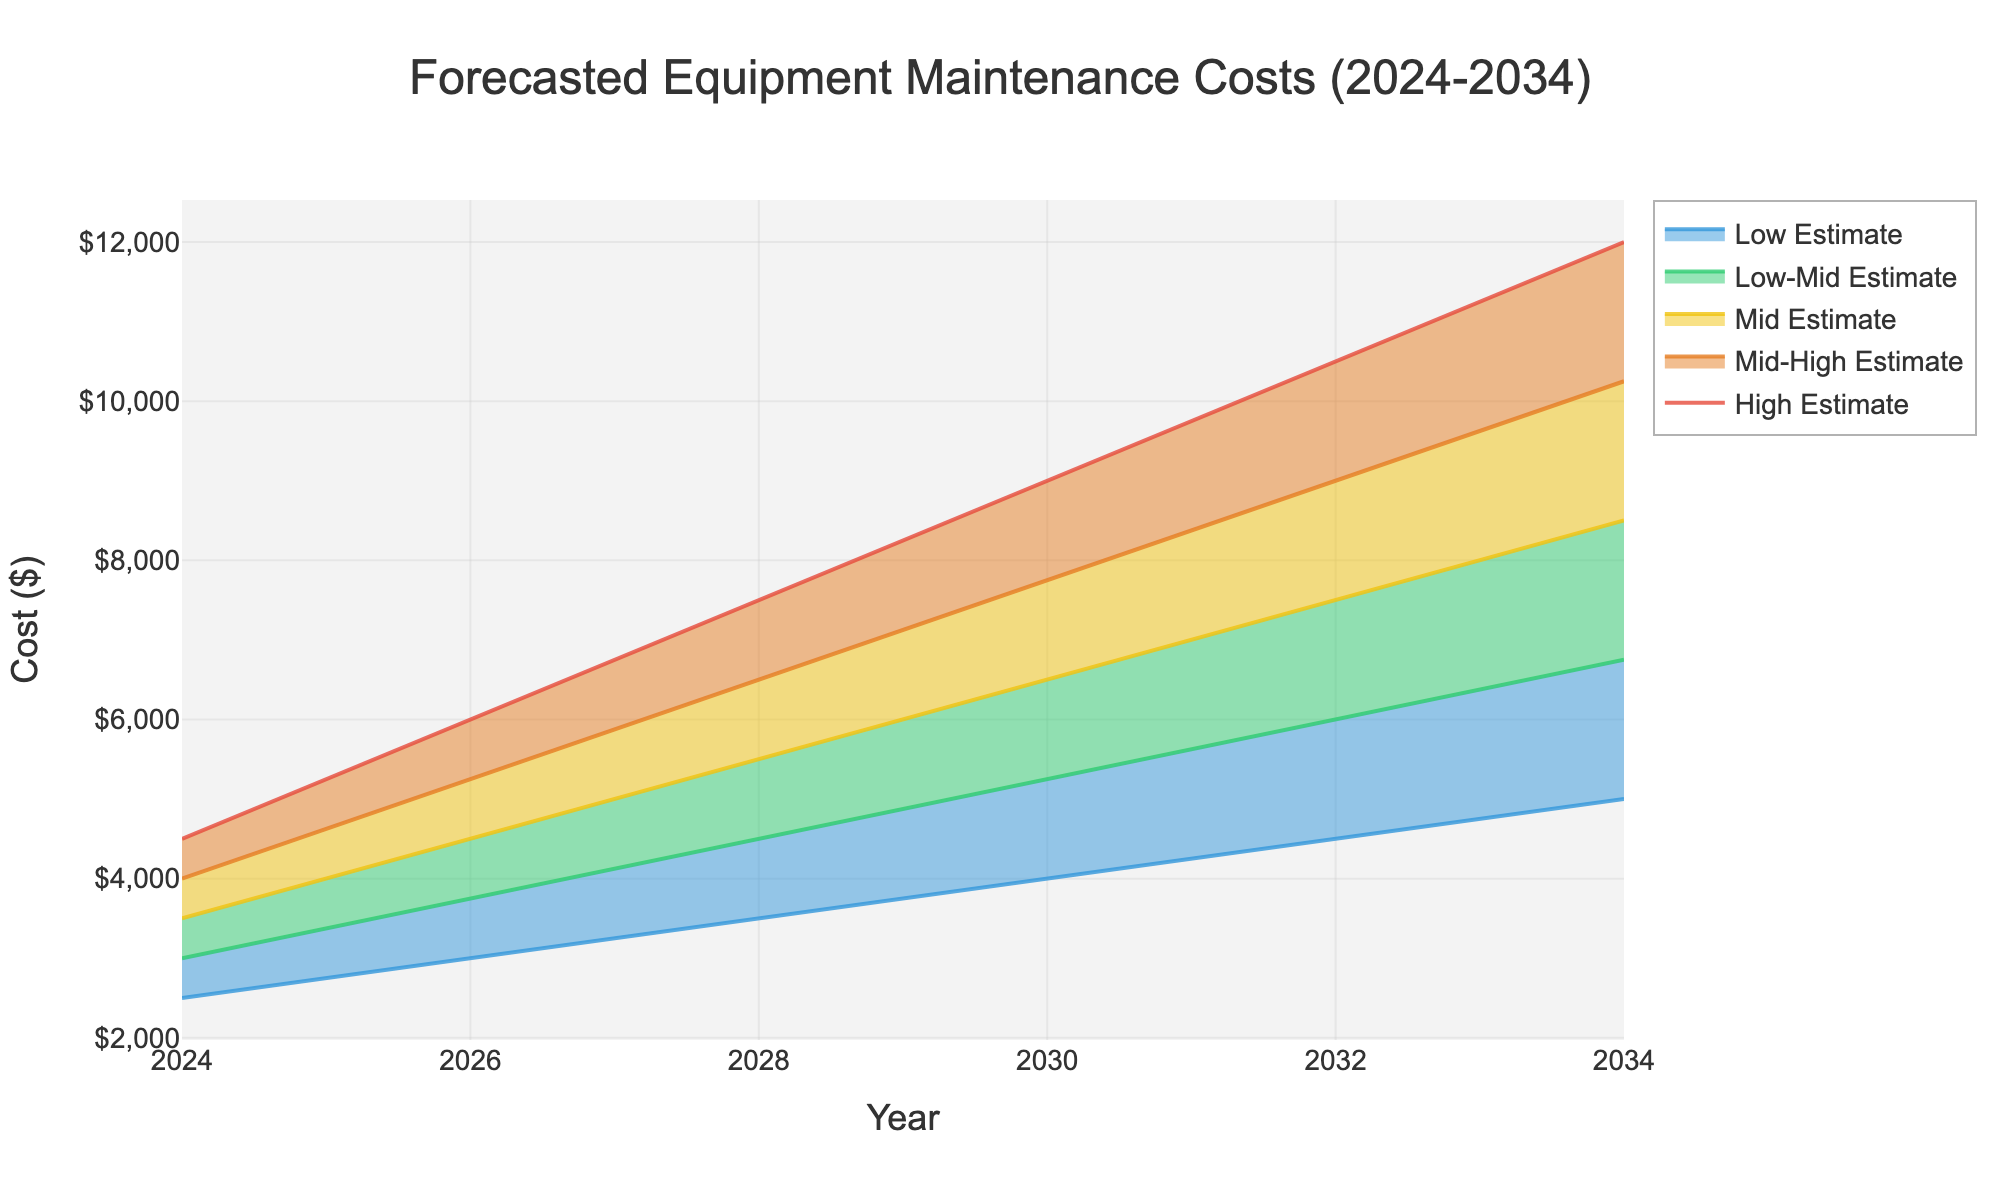What's the title of the figure? The title is often located at the top center of the figure and it provides an overall summary of what the figure represents. Here, the title would be found above the fan chart.
Answer: Forecasted Equipment Maintenance Costs (2024-2034) How many years are forecasted in the fan chart? To find this, count the number of years along the x-axis that have data points associated with them.
Answer: 6 What's the estimated high maintenance cost in 2034? On the fan chart, locate the year 2034 on the x-axis and trace upwards to where it intersects with the 'High Estimate' line. The y-value at this intersection is the high maintenance cost estimate for that year.
Answer: $12,000 What is the difference between the high estimate and the low estimate for 2024? Identify the y-values for the 'High Estimate' and 'Low Estimate' lines for the year 2024. Subtract the low estimate from the high estimate to find the difference.
Answer: $4,000 In which year is the mid estimate expected to be $6,500? Locate the 'Mid Estimate' line and find the data point where the y-value is $6,500. Trace this point directly down to the x-axis to determine the year.
Answer: 2030 How much higher is the mid-high estimate than the mid estimate in 2028? Find the 'Mid-High Estimate' and 'Mid Estimate' lines for the year 2028. Subtract the mid estimate from the mid-high estimate for that year.
Answer: $1,000 Which estimate shows the smallest growth from 2024 to 2026? Calculate the growth for each estimate by subtracting values in 2024 from values in 2026. The estimate with the smallest difference represents the smallest growth.
Answer: Low-Mid Estimate What's the average value of the mid estimate over the entire period? Sum the y-values of the 'Mid Estimate' line across all years and then divide by the number of years. Calculations: (3500 + 4500 + 5500 + 6500 + 7500 + 8500) / 6 = 45000 / 6
Answer: $7,500 In which year does the fan of estimates widen the most? Determine the width by comparing the difference between the high and low estimates for each year. The year with the largest difference indicates the widest fan. From the given data: 9000 - 4000 = 5000 for 2030, 12000 - 5000 = 7000 for 2034, etc.
Answer: 2034 